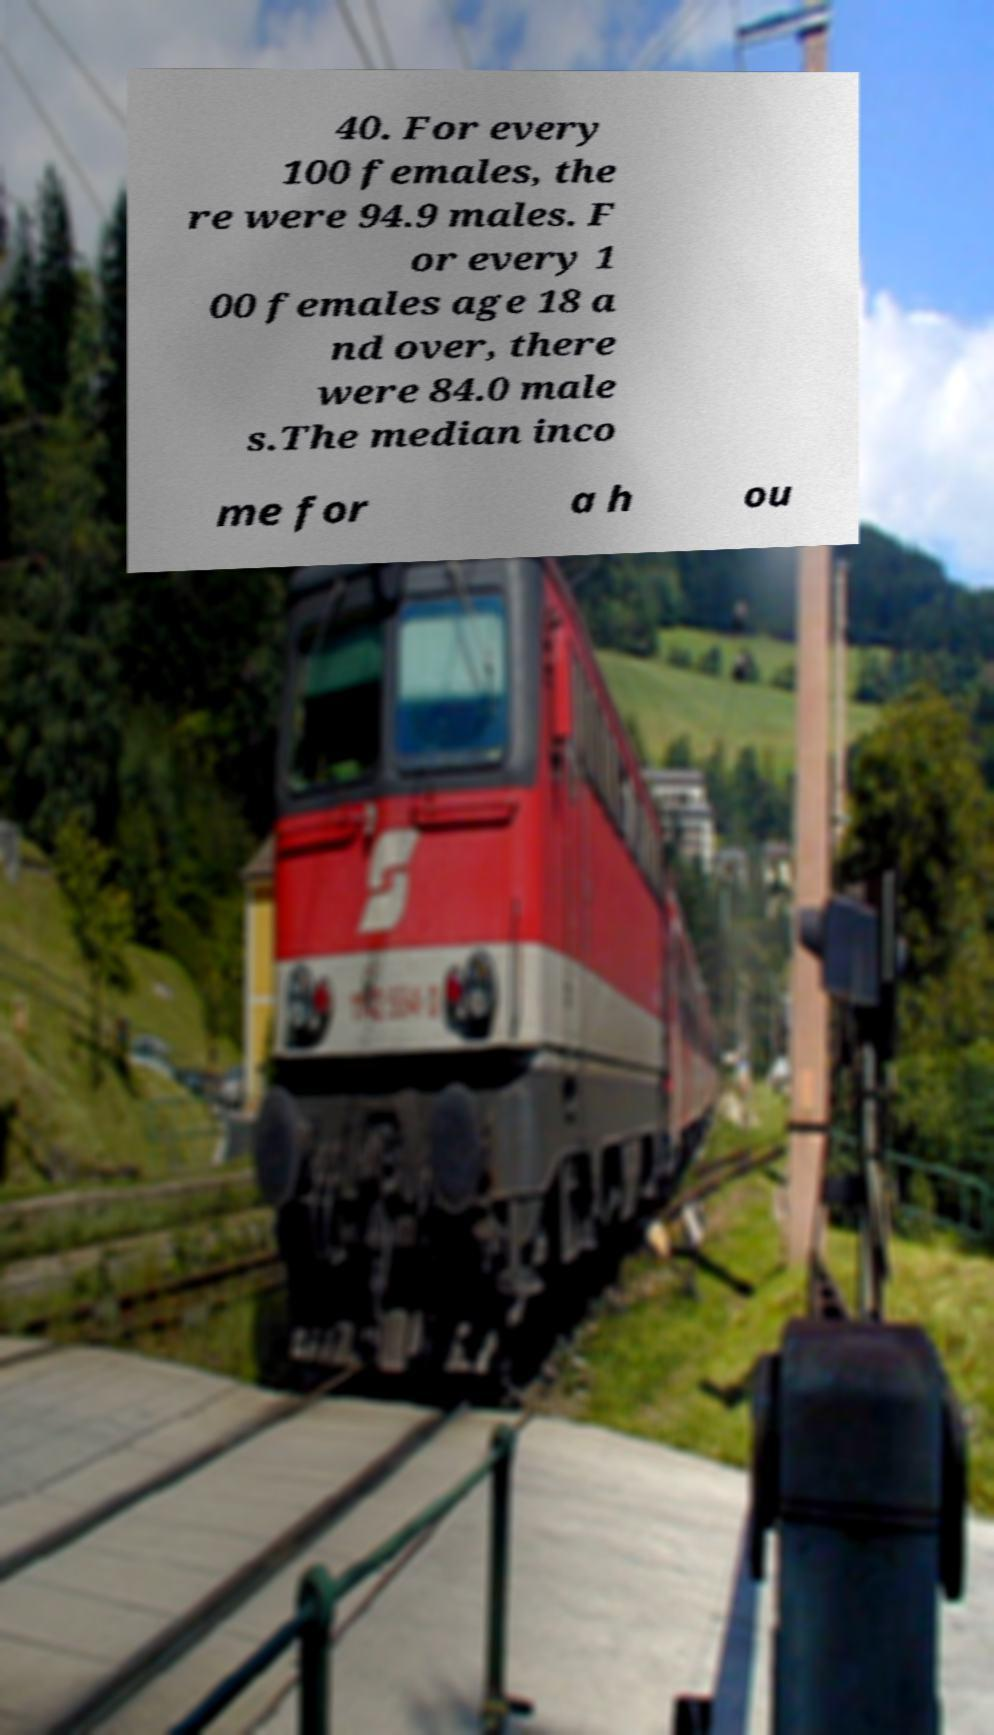For documentation purposes, I need the text within this image transcribed. Could you provide that? 40. For every 100 females, the re were 94.9 males. F or every 1 00 females age 18 a nd over, there were 84.0 male s.The median inco me for a h ou 